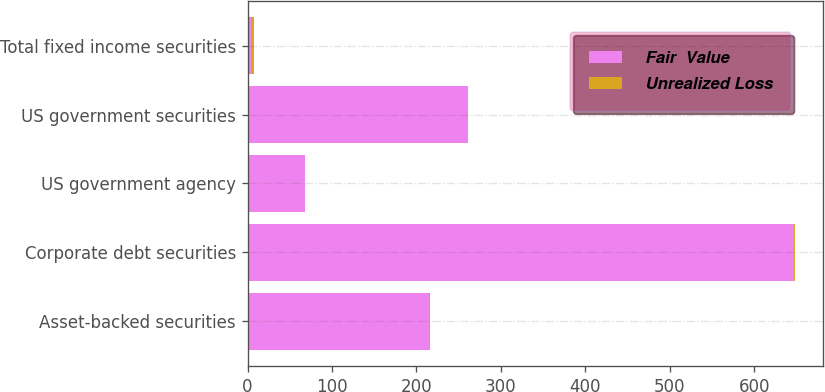Convert chart to OTSL. <chart><loc_0><loc_0><loc_500><loc_500><stacked_bar_chart><ecel><fcel>Asset-backed securities<fcel>Corporate debt securities<fcel>US government agency<fcel>US government securities<fcel>Total fixed income securities<nl><fcel>Fair  Value<fcel>215.2<fcel>646.7<fcel>68.3<fcel>260.8<fcel>3.6<nl><fcel>Unrealized Loss<fcel>0.4<fcel>2.1<fcel>0.2<fcel>0.7<fcel>3.6<nl></chart> 